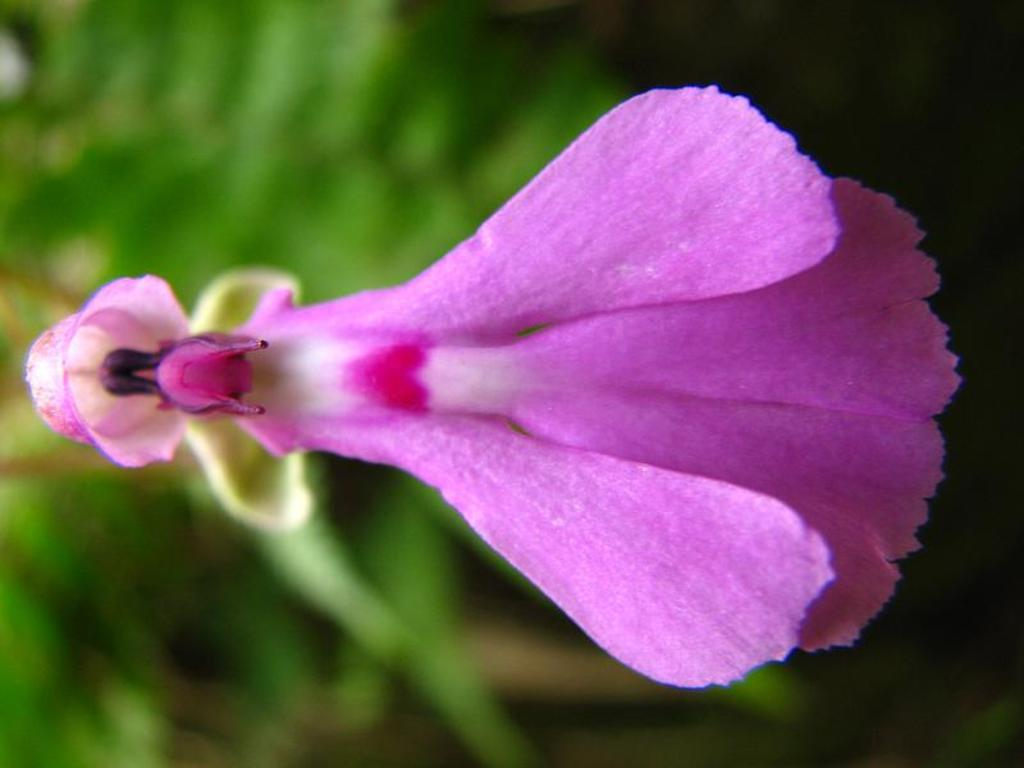What is the main subject of the image? There is a flower in the center of the image. What color is the flower? The flower is purple. What can be seen in the background of the image? There are trees in the background of the image. Can you tell me how many toads are sitting on the flower in the image? There are no toads present in the image; it features a purple flower with trees in the background. What emotion is the flower displaying in the image? The flower is an inanimate object and does not display emotions like anger. 